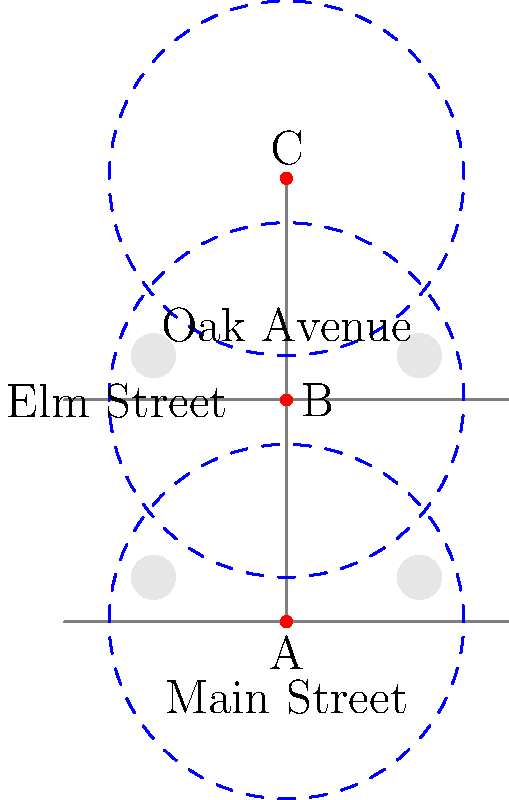In Strelley village, the council is planning to install streetlights to improve safety while minimizing light pollution for nocturnal animals. The diagram shows the layout of three main streets with houses (gray circles) and proposed streetlight locations (red dots A, B, and C). Each streetlight has a coverage radius of 40 meters (blue dashed circles). What is the minimum number of streetlights needed to cover all street intersections while ensuring that no light directly shines on the houses? To solve this problem, we need to consider the coverage of each streetlight and its impact on the houses:

1. Analyze the coverage of each streetlight:
   - Streetlight A covers the southern intersection and part of Main Street and Elm Street.
   - Streetlight B covers the central intersection and parts of all three streets.
   - Streetlight C covers the northern intersection and part of Oak Avenue and Elm Street.

2. Check the impact on houses:
   - The houses are located at (20,10), (80,10), (20,60), and (80,60).
   - None of the proposed streetlight locations directly shine on the houses, as they are outside the 40-meter radius.

3. Determine the minimum number of streetlights needed:
   - To cover all intersections, we need at least two streetlights.
   - Streetlight B alone is not sufficient, as it doesn't fully cover the northern and southern intersections.
   - We have two options:
     a) Use streetlights A and C
     b) Use all three streetlights A, B, and C

4. Consider the optimal solution:
   - Using only streetlights A and C would leave the central part of Elm Street poorly lit.
   - Using all three streetlights provides better coverage of the streets without increasing light pollution for the houses.

Therefore, the optimal solution is to use all three streetlights (A, B, and C) to ensure maximum coverage of the street intersections and main streets while minimizing light pollution for the houses and nocturnal animals.
Answer: 3 streetlights 